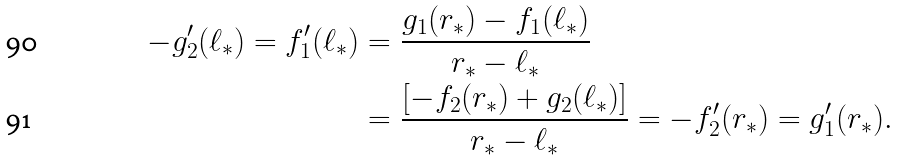<formula> <loc_0><loc_0><loc_500><loc_500>- g _ { 2 } ^ { \prime } ( \ell _ { * } ) = f _ { 1 } ^ { \prime } ( \ell _ { * } ) & = \frac { g _ { 1 } ( r _ { * } ) - f _ { 1 } ( \ell _ { * } ) } { r _ { * } - \ell _ { * } } \\ & = \frac { [ - f _ { 2 } ( r _ { * } ) + g _ { 2 } ( \ell _ { * } ) ] } { r _ { * } - \ell _ { * } } = - f _ { 2 } ^ { \prime } ( r _ { * } ) = g _ { 1 } ^ { \prime } ( r _ { * } ) .</formula> 